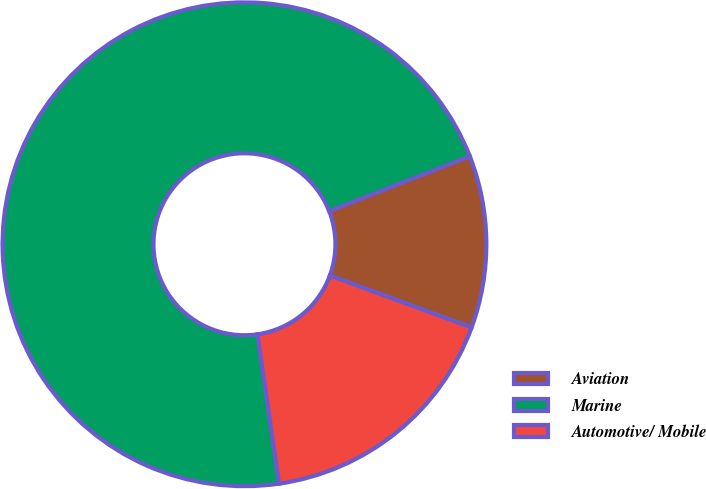<chart> <loc_0><loc_0><loc_500><loc_500><pie_chart><fcel>Aviation<fcel>Marine<fcel>Automotive/ Mobile<nl><fcel>11.52%<fcel>71.35%<fcel>17.13%<nl></chart> 